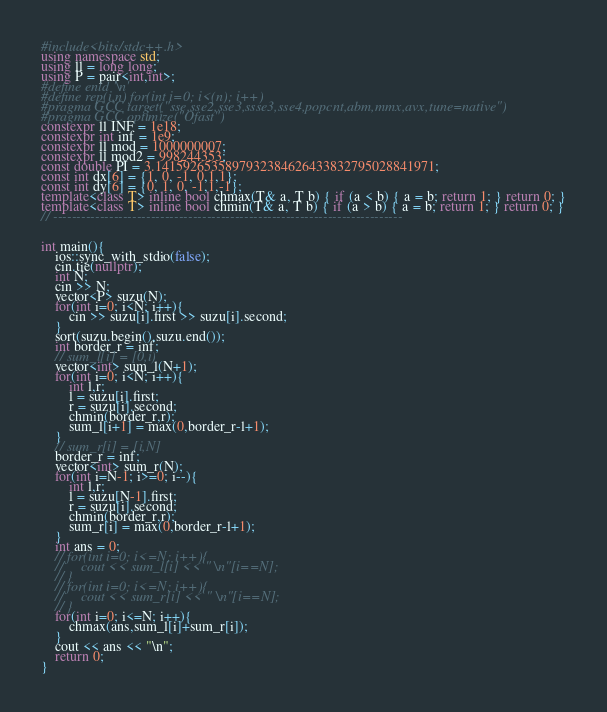Convert code to text. <code><loc_0><loc_0><loc_500><loc_500><_C++_>#include<bits/stdc++.h>
using namespace std;
using ll = long long;
using P = pair<int,int>;
#define enld '\n'
#define rep(i,n) for(int i=0; i<(n); i++)
#pragma GCC target("sse,sse2,sse3,ssse3,sse4,popcnt,abm,mmx,avx,tune=native")
#pragma GCC optimize("Ofast")
constexpr ll INF = 1e18;
constexpr int inf = 1e9;
constexpr ll mod = 1000000007;
constexpr ll mod2 = 998244353;
const double PI = 3.1415926535897932384626433832795028841971;
const int dx[6] = {1, 0, -1, 0,1,1};
const int dy[6] = {0, 1, 0, -1,1,-1};
template<class T> inline bool chmax(T& a, T b) { if (a < b) { a = b; return 1; } return 0; }
template<class T> inline bool chmin(T& a, T b) { if (a > b) { a = b; return 1; } return 0; }
// ---------------------------------------------------------------------------


int main(){
    ios::sync_with_stdio(false);
    cin.tie(nullptr);
    int N;
    cin >> N;
    vector<P> suzu(N);
    for(int i=0; i<N; i++){
        cin >> suzu[i].first >> suzu[i].second;
    }
    sort(suzu.begin(),suzu.end());
    int border_r = inf;
    // sum_l[i] = [0,i)
    vector<int> sum_l(N+1);
    for(int i=0; i<N; i++){
        int l,r;
        l = suzu[i].first;
        r = suzu[i].second;
        chmin(border_r,r);
        sum_l[i+1] = max(0,border_r-l+1);
    }
    // sum_r[i] = [i,N]
    border_r = inf;
    vector<int> sum_r(N);
    for(int i=N-1; i>=0; i--){
        int l,r;
        l = suzu[N-1].first;
        r = suzu[i].second;
        chmin(border_r,r);
        sum_r[i] = max(0,border_r-l+1);
    }
    int ans = 0;
    // for(int i=0; i<=N; i++){
    //     cout << sum_l[i] << " \n"[i==N];
    // }
    // for(int i=0; i<=N; i++){
    //     cout << sum_r[i] << " \n"[i==N];
    // }
    for(int i=0; i<=N; i++){
        chmax(ans,sum_l[i]+sum_r[i]);
    }
    cout << ans << "\n";
    return 0;
}</code> 